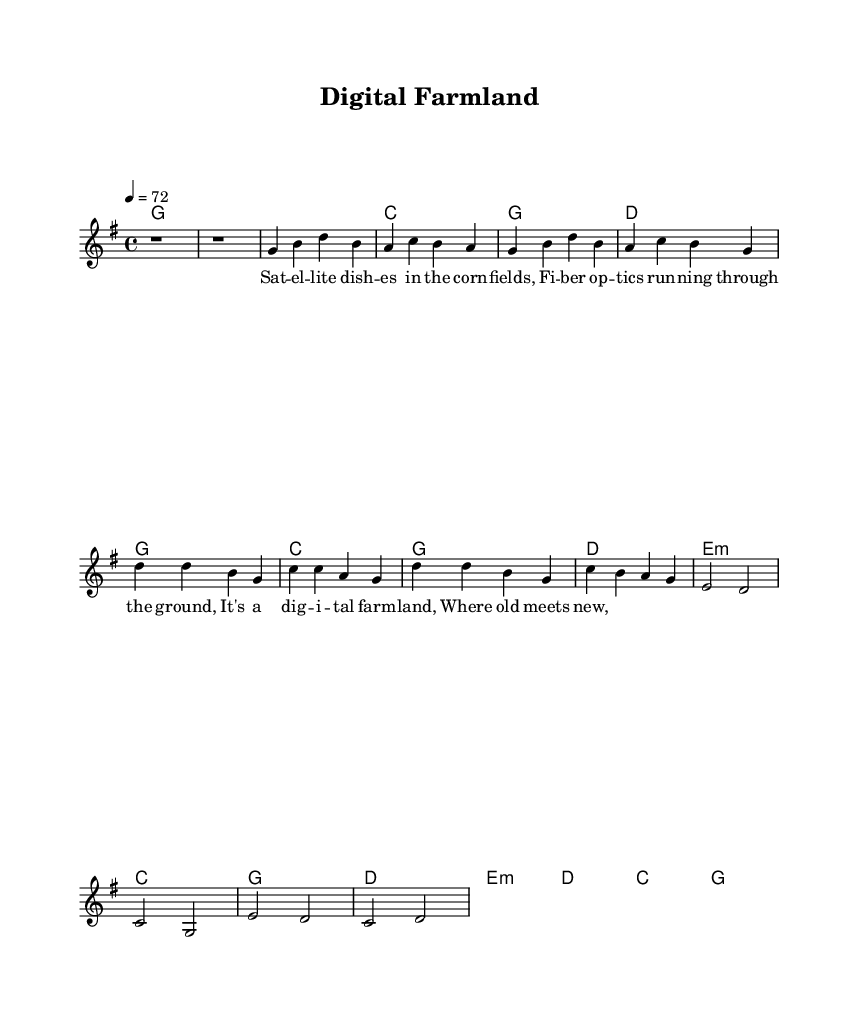What is the key signature of this music? The key signature is G major, which has one sharp (F#). This can be identified in the beginning of the sheet music where the key is indicated in the global section.
Answer: G major What is the time signature of the piece? The time signature is 4/4, which is specified in the global section of the score. In 4/4 time, each measure contains four beats, making it a common time signature in many genres, including country rock.
Answer: 4/4 What is the tempo marking of the music? The tempo marking is 72, indicated by "4 = 72" in the global section. This means that there are 72 beats per minute, giving the piece a moderate pace.
Answer: 72 How many measures are in the chorus section? The chorus section consists of four measures. By examining the notation, you will notice that it contains a distinct melody and harmony that are repeated over those four measures.
Answer: 4 What type of harmonic progression is used in the verse? The verse uses a I-IV-V progression, which is common in country rock music. Identifying the chords in the verse (G, C, and D) shows this structure, typical for building tension and support for the melody.
Answer: I-IV-V What is the primary theme represented in the lyrics? The primary theme in the lyrics revolves around the fusion of technology and rural life, as highlighted by references to satellite dishes and fiber optics, common in modern agricultural practices.
Answer: Technology and rural life What is the overall mood or feeling conveyed by the music? The overall mood conveyed by this country rock ballad is reflective and nostalgic, as it combines traditional themes of rural life with modern technological advancements, creating a sense of continuity and change.
Answer: Reflective and nostalgic 